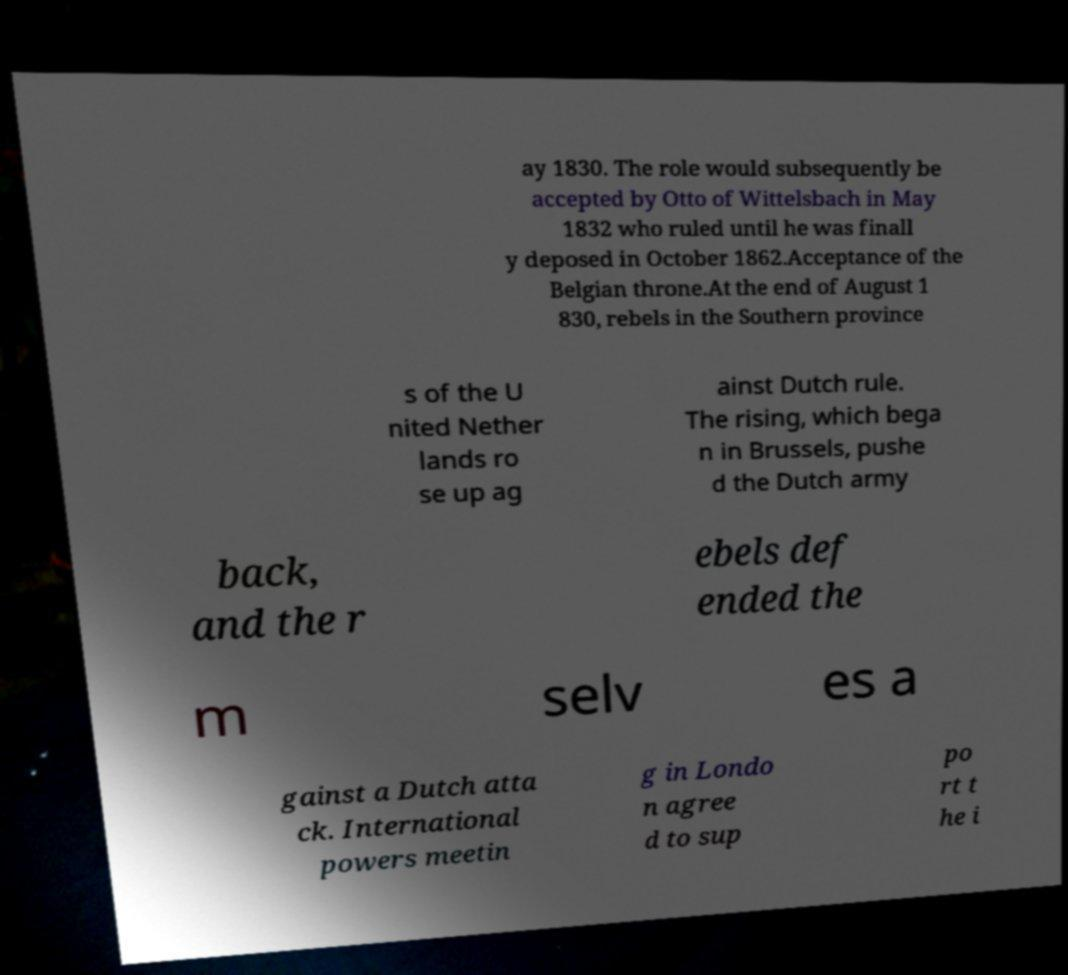Could you assist in decoding the text presented in this image and type it out clearly? ay 1830. The role would subsequently be accepted by Otto of Wittelsbach in May 1832 who ruled until he was finall y deposed in October 1862.Acceptance of the Belgian throne.At the end of August 1 830, rebels in the Southern province s of the U nited Nether lands ro se up ag ainst Dutch rule. The rising, which bega n in Brussels, pushe d the Dutch army back, and the r ebels def ended the m selv es a gainst a Dutch atta ck. International powers meetin g in Londo n agree d to sup po rt t he i 